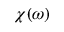Convert formula to latex. <formula><loc_0><loc_0><loc_500><loc_500>\chi ( \omega )</formula> 